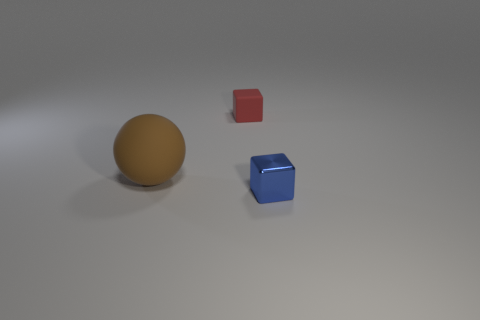There is another small thing that is the same shape as the small metallic thing; what is its material?
Provide a succinct answer. Rubber. There is a small object behind the small blue thing; what is its color?
Offer a very short reply. Red. The blue metal thing has what size?
Provide a short and direct response. Small. Do the matte cube and the thing in front of the big rubber ball have the same size?
Keep it short and to the point. Yes. What is the color of the thing to the left of the cube to the left of the small object in front of the large brown sphere?
Make the answer very short. Brown. Do the cube that is in front of the large brown matte sphere and the large brown sphere have the same material?
Keep it short and to the point. No. How many other objects are the same material as the small red object?
Ensure brevity in your answer.  1. There is a red cube that is the same size as the blue metallic object; what material is it?
Your answer should be compact. Rubber. There is a small thing in front of the red rubber thing; is it the same shape as the rubber thing to the right of the large brown thing?
Keep it short and to the point. Yes. What shape is the blue object that is the same size as the red rubber cube?
Offer a very short reply. Cube. 